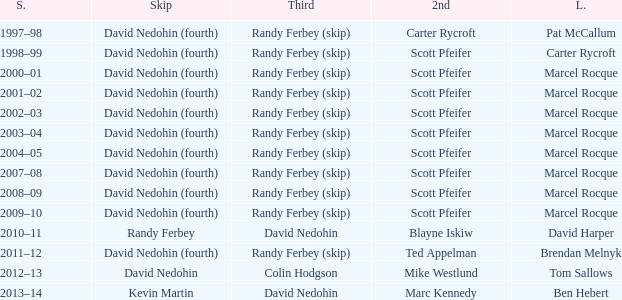Would you mind parsing the complete table? {'header': ['S.', 'Skip', 'Third', '2nd', 'L.'], 'rows': [['1997–98', 'David Nedohin (fourth)', 'Randy Ferbey (skip)', 'Carter Rycroft', 'Pat McCallum'], ['1998–99', 'David Nedohin (fourth)', 'Randy Ferbey (skip)', 'Scott Pfeifer', 'Carter Rycroft'], ['2000–01', 'David Nedohin (fourth)', 'Randy Ferbey (skip)', 'Scott Pfeifer', 'Marcel Rocque'], ['2001–02', 'David Nedohin (fourth)', 'Randy Ferbey (skip)', 'Scott Pfeifer', 'Marcel Rocque'], ['2002–03', 'David Nedohin (fourth)', 'Randy Ferbey (skip)', 'Scott Pfeifer', 'Marcel Rocque'], ['2003–04', 'David Nedohin (fourth)', 'Randy Ferbey (skip)', 'Scott Pfeifer', 'Marcel Rocque'], ['2004–05', 'David Nedohin (fourth)', 'Randy Ferbey (skip)', 'Scott Pfeifer', 'Marcel Rocque'], ['2007–08', 'David Nedohin (fourth)', 'Randy Ferbey (skip)', 'Scott Pfeifer', 'Marcel Rocque'], ['2008–09', 'David Nedohin (fourth)', 'Randy Ferbey (skip)', 'Scott Pfeifer', 'Marcel Rocque'], ['2009–10', 'David Nedohin (fourth)', 'Randy Ferbey (skip)', 'Scott Pfeifer', 'Marcel Rocque'], ['2010–11', 'Randy Ferbey', 'David Nedohin', 'Blayne Iskiw', 'David Harper'], ['2011–12', 'David Nedohin (fourth)', 'Randy Ferbey (skip)', 'Ted Appelman', 'Brendan Melnyk'], ['2012–13', 'David Nedohin', 'Colin Hodgson', 'Mike Westlund', 'Tom Sallows'], ['2013–14', 'Kevin Martin', 'David Nedohin', 'Marc Kennedy', 'Ben Hebert']]} Which Skip has a Season of 2002–03? David Nedohin (fourth). 